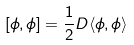Convert formula to latex. <formula><loc_0><loc_0><loc_500><loc_500>[ \phi , \phi ] = \frac { 1 } { 2 } D \langle \phi , \phi \rangle</formula> 